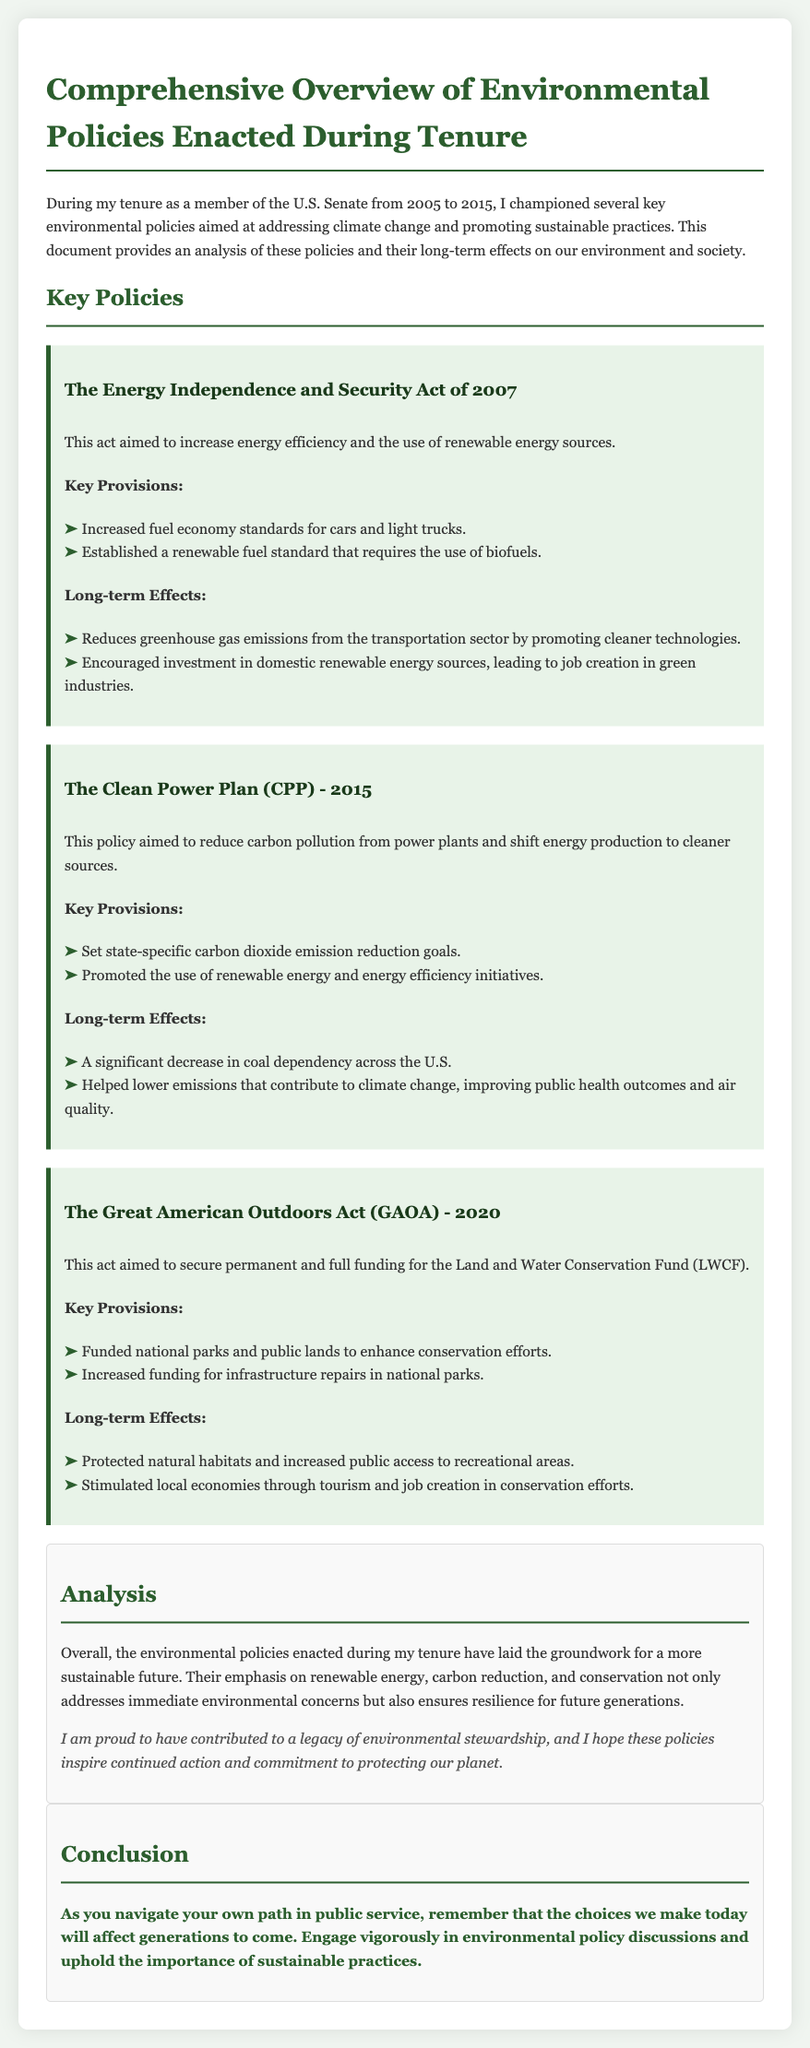what is the title of the document? The title of the document is presented at the top of the content.
Answer: Comprehensive Overview of Environmental Policies Enacted During Tenure what act aimed to increase energy efficiency? This act is explicitly mentioned as a key policy in the document's section on key policies.
Answer: The Energy Independence and Security Act of 2007 which year was the Clean Power Plan enacted? The enactment year for the Clean Power Plan is stated clearly in the document.
Answer: 2015 what are the key provisions of the Great American Outdoors Act? The document lists relevant details under the sections discussing key provisions for the policy.
Answer: Funded national parks and public lands to enhance conservation efforts; Increased funding for infrastructure repairs in national parks how did the Energy Independence and Security Act of 2007 affect greenhouse gas emissions? The document notes the long-term effects of the act, specifically related to emissions.
Answer: Reduces greenhouse gas emissions from the transportation sector what is the primary goal of the Clean Power Plan? The main objective of the Clean Power Plan can be inferred from the policy's description in the document.
Answer: Reduce carbon pollution from power plants how did the policies during the tenure promote job creation? This effect is discussed in relation to specific policies in the document.
Answer: Encouraged investment in domestic renewable energy sources what is emphasized in the analysis section of the document? The analysis section summarizes the overall impact and future implications of the policies.
Answer: A more sustainable future what call to action is mentioned in the conclusion? The conclusion of the document contains a specific directive for the reader.
Answer: Engage vigorously in environmental policy discussions 